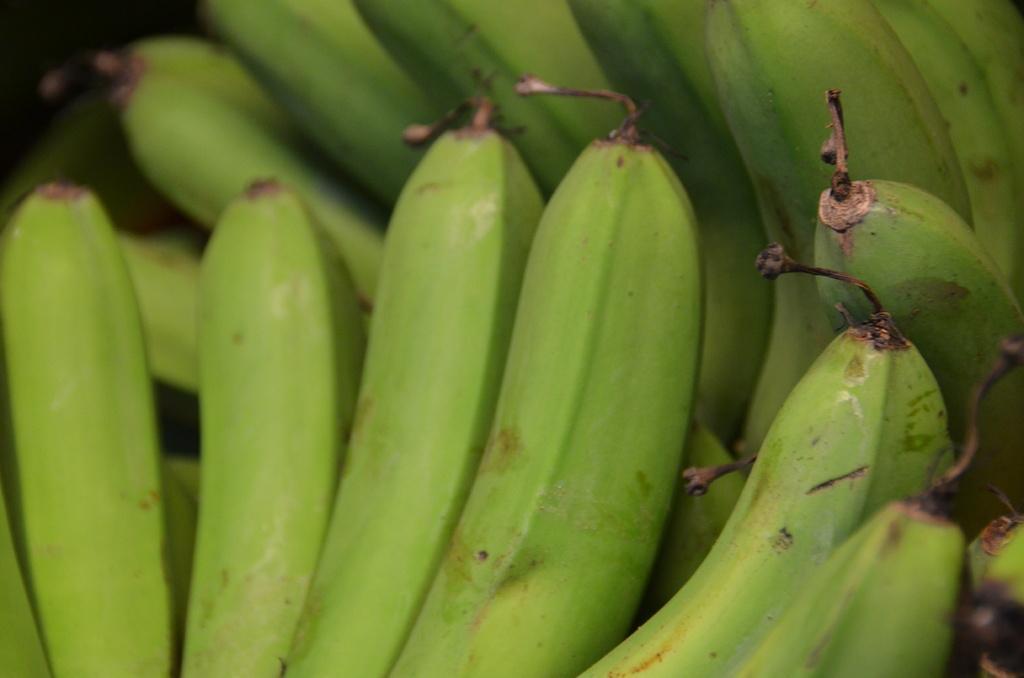Can you describe this image briefly? In this image, I can see the bunches of green bananas. 